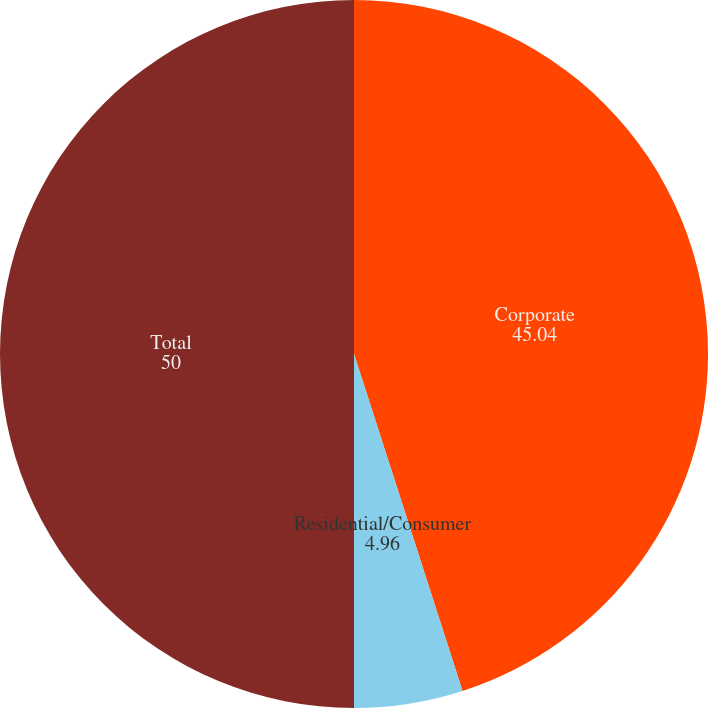<chart> <loc_0><loc_0><loc_500><loc_500><pie_chart><fcel>Corporate<fcel>Residential/Consumer<fcel>Total<nl><fcel>45.04%<fcel>4.96%<fcel>50.0%<nl></chart> 